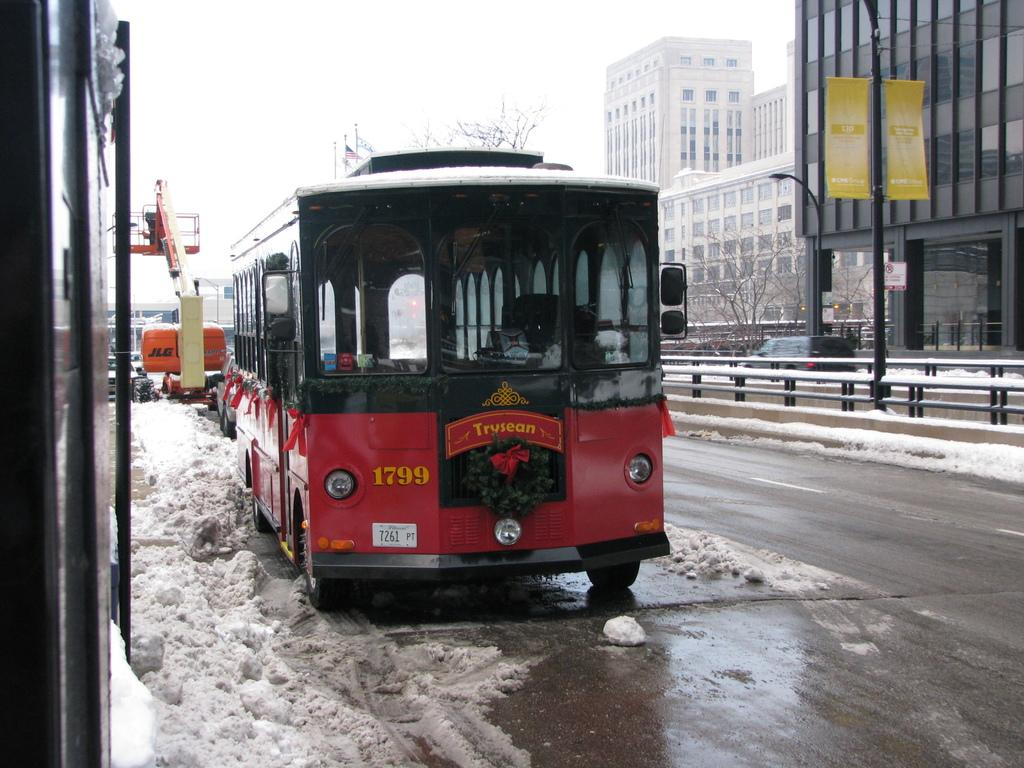<image>
Share a concise interpretation of the image provided. 1799 is written on the front of a red trolley above the license plate 